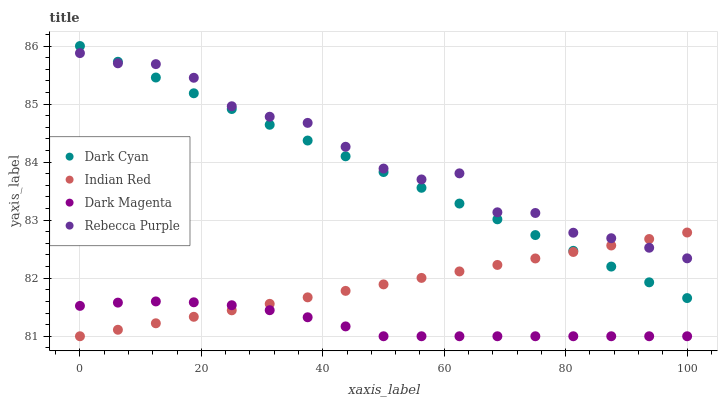Does Dark Magenta have the minimum area under the curve?
Answer yes or no. Yes. Does Rebecca Purple have the maximum area under the curve?
Answer yes or no. Yes. Does Indian Red have the minimum area under the curve?
Answer yes or no. No. Does Indian Red have the maximum area under the curve?
Answer yes or no. No. Is Dark Cyan the smoothest?
Answer yes or no. Yes. Is Rebecca Purple the roughest?
Answer yes or no. Yes. Is Dark Magenta the smoothest?
Answer yes or no. No. Is Dark Magenta the roughest?
Answer yes or no. No. Does Dark Magenta have the lowest value?
Answer yes or no. Yes. Does Rebecca Purple have the lowest value?
Answer yes or no. No. Does Dark Cyan have the highest value?
Answer yes or no. Yes. Does Indian Red have the highest value?
Answer yes or no. No. Is Dark Magenta less than Rebecca Purple?
Answer yes or no. Yes. Is Dark Cyan greater than Dark Magenta?
Answer yes or no. Yes. Does Rebecca Purple intersect Dark Cyan?
Answer yes or no. Yes. Is Rebecca Purple less than Dark Cyan?
Answer yes or no. No. Is Rebecca Purple greater than Dark Cyan?
Answer yes or no. No. Does Dark Magenta intersect Rebecca Purple?
Answer yes or no. No. 